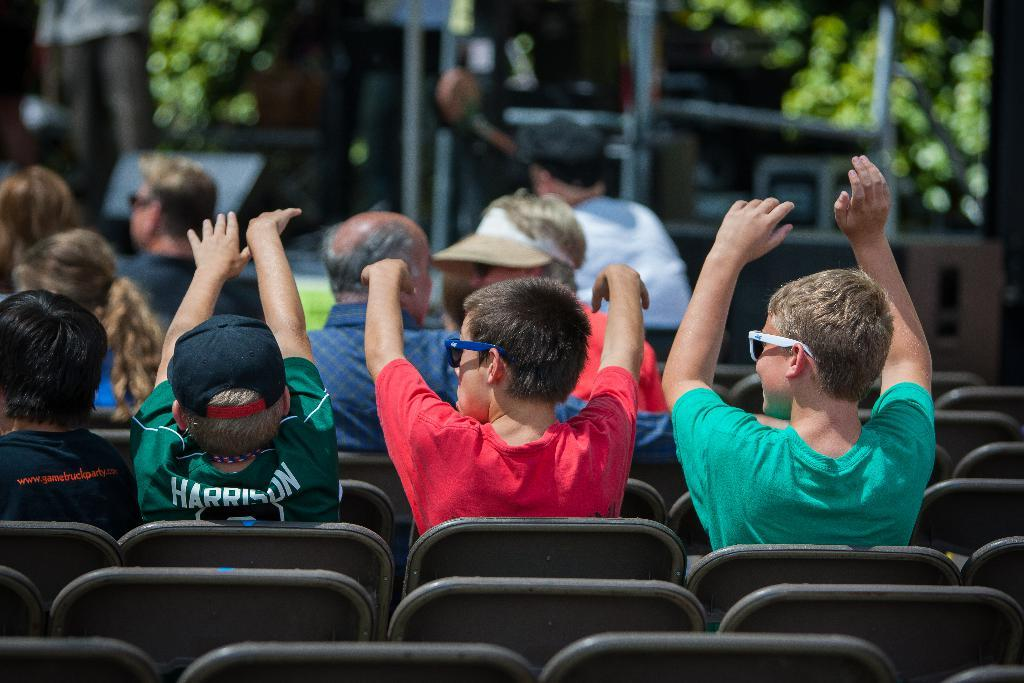What is happening in the image involving a group of people? There is a group of people in the image, and they are sitting on chairs. Are there any specific actions being performed by the people in the image? Yes, some people are raising their hands. Can you describe the background of the image? The background of the image is blurry. What type of drain is visible in the image? There is no drain present in the image. How does the lock on the door in the image work? There is no door or lock present in the image. 